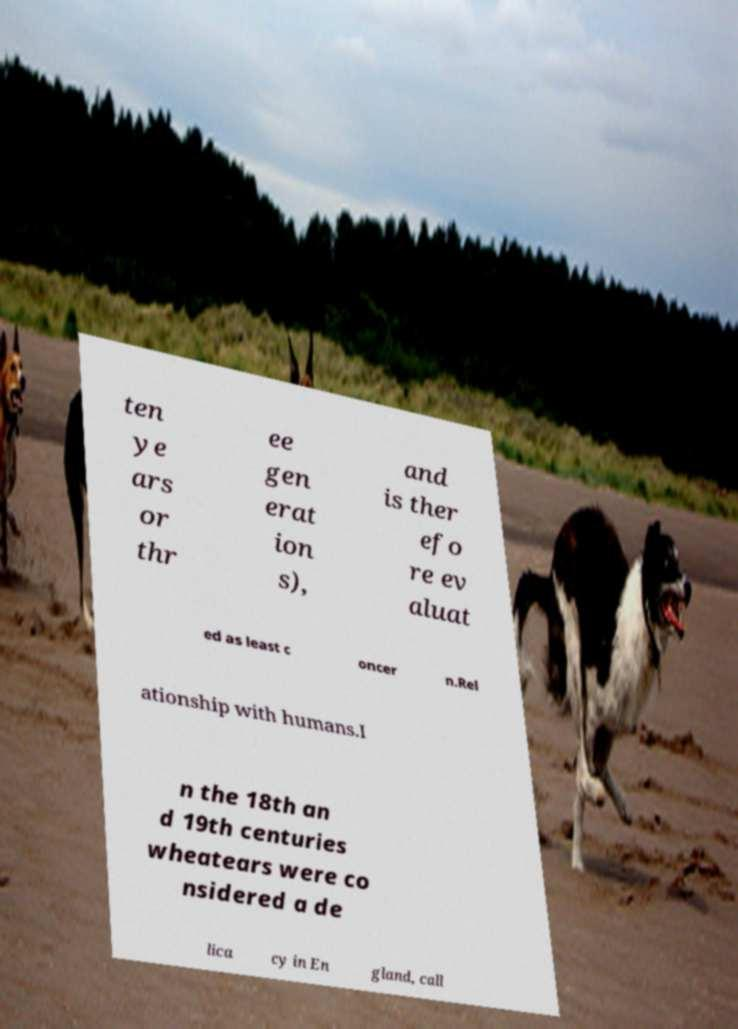Can you accurately transcribe the text from the provided image for me? ten ye ars or thr ee gen erat ion s), and is ther efo re ev aluat ed as least c oncer n.Rel ationship with humans.I n the 18th an d 19th centuries wheatears were co nsidered a de lica cy in En gland, call 